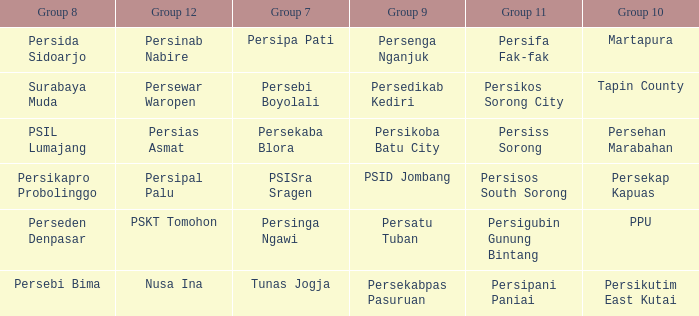Who played in group 11 when Persipal Palu played in group 12? Persisos South Sorong. 